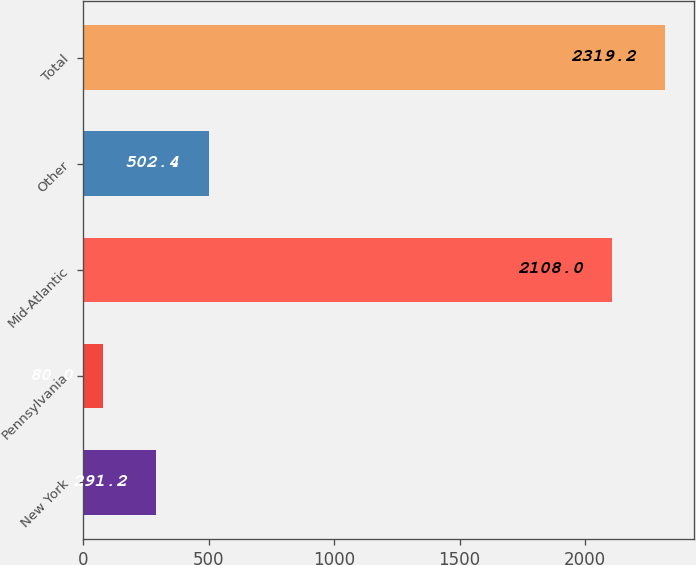<chart> <loc_0><loc_0><loc_500><loc_500><bar_chart><fcel>New York<fcel>Pennsylvania<fcel>Mid-Atlantic<fcel>Other<fcel>Total<nl><fcel>291.2<fcel>80<fcel>2108<fcel>502.4<fcel>2319.2<nl></chart> 